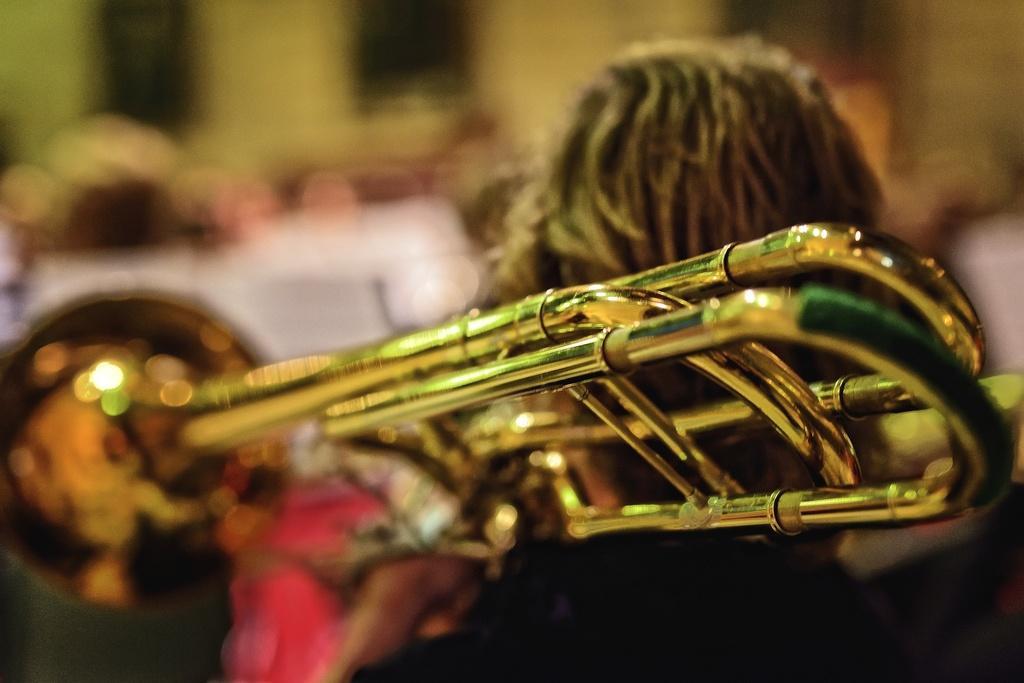Can you describe this image briefly? In this image there is a person holding a trumpet and there are group of people standing in the background. 